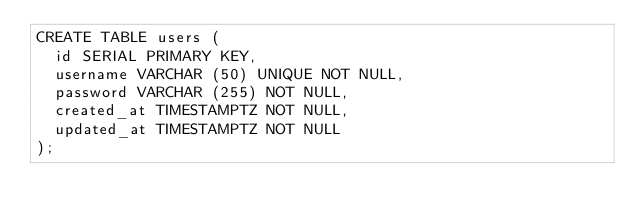<code> <loc_0><loc_0><loc_500><loc_500><_SQL_>CREATE TABLE users (
  id SERIAL PRIMARY KEY,
  username VARCHAR (50) UNIQUE NOT NULL,
  password VARCHAR (255) NOT NULL,
  created_at TIMESTAMPTZ NOT NULL,
  updated_at TIMESTAMPTZ NOT NULL
);
</code> 